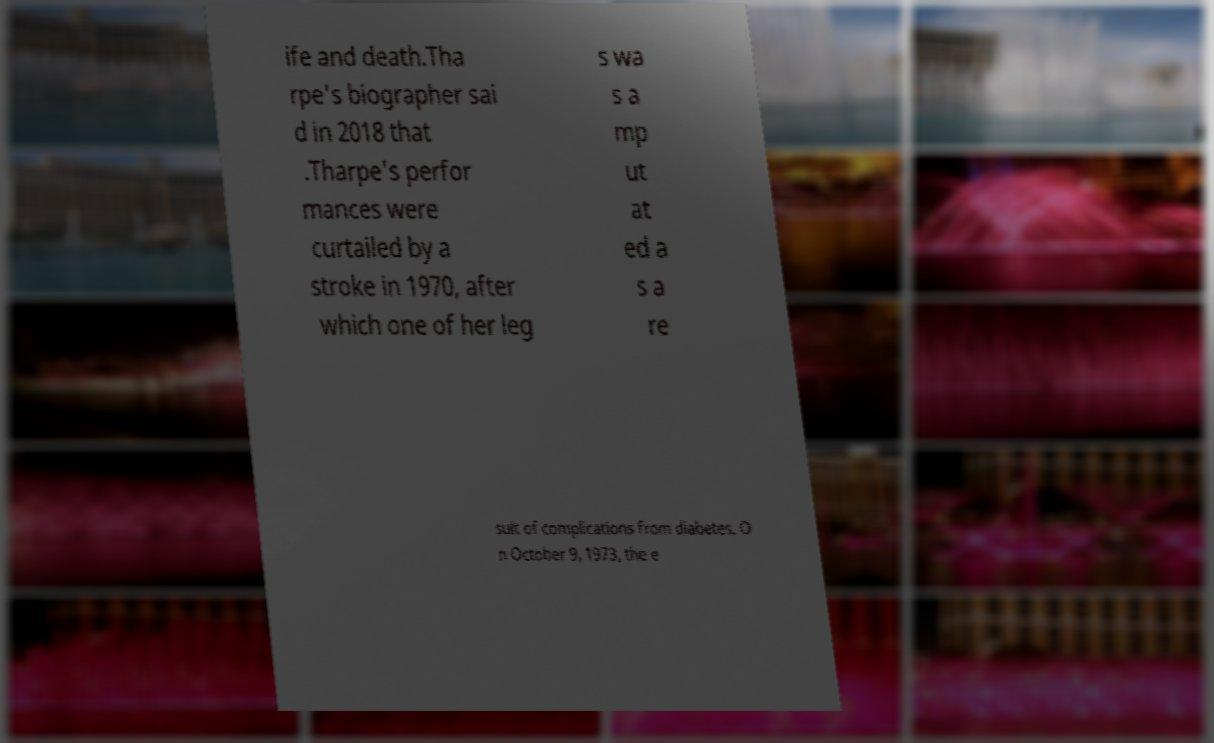For documentation purposes, I need the text within this image transcribed. Could you provide that? ife and death.Tha rpe's biographer sai d in 2018 that .Tharpe's perfor mances were curtailed by a stroke in 1970, after which one of her leg s wa s a mp ut at ed a s a re sult of complications from diabetes. O n October 9, 1973, the e 